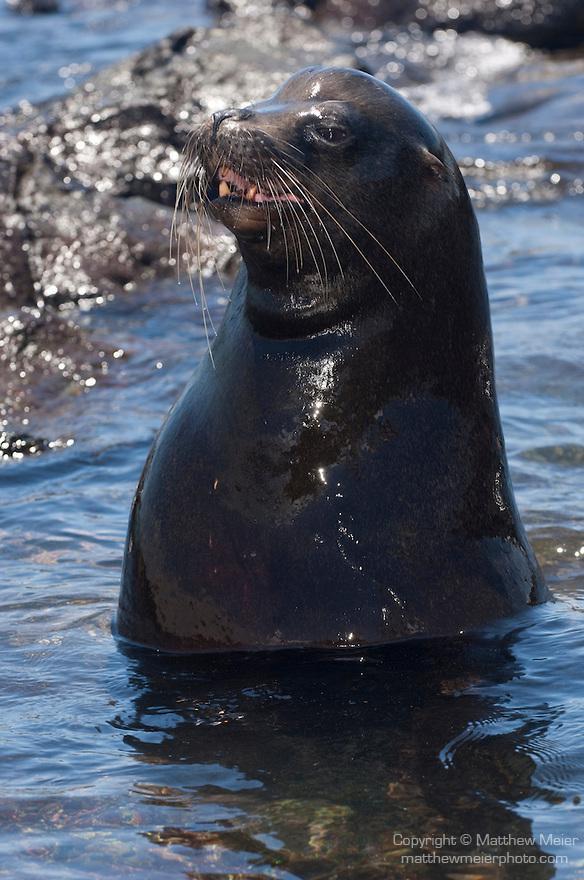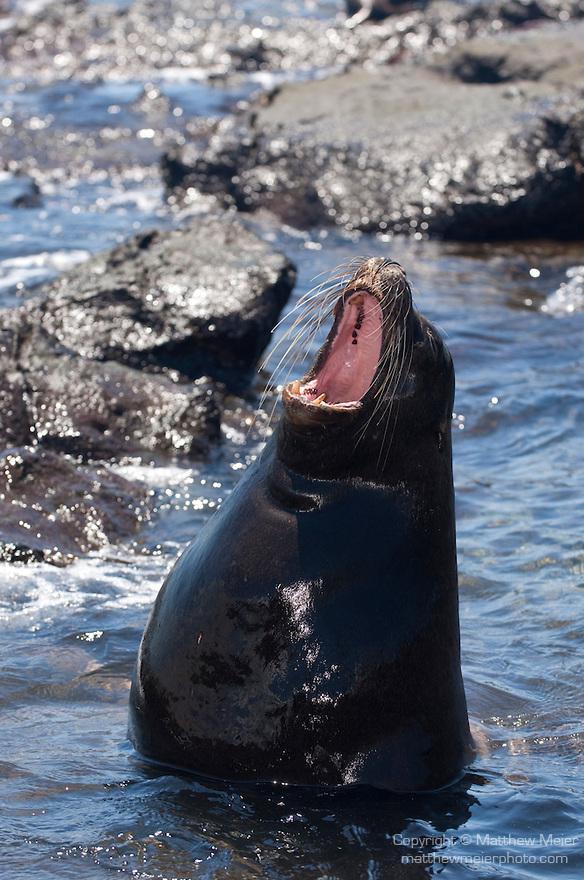The first image is the image on the left, the second image is the image on the right. Analyze the images presented: Is the assertion "The left image contains no more than one seal." valid? Answer yes or no. Yes. 